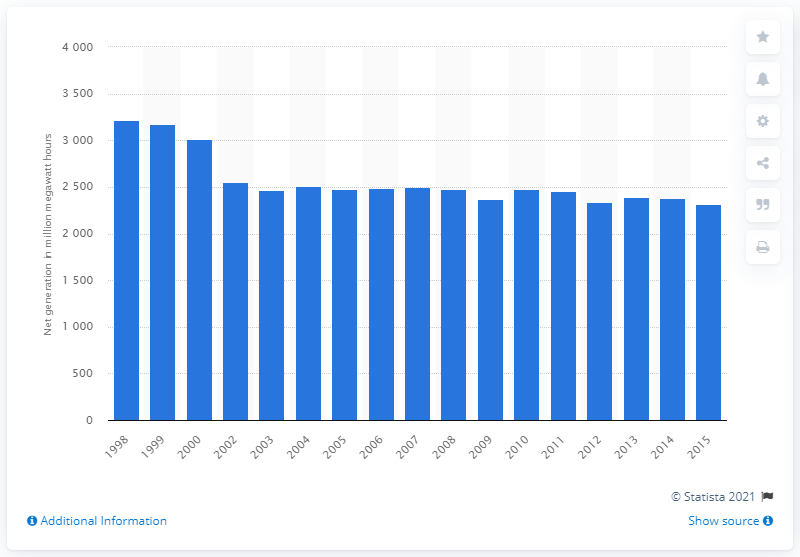Indicate a few pertinent items in this graphic. In 2015, electric utilities generated 23,150 megawatt hours of electricity. 